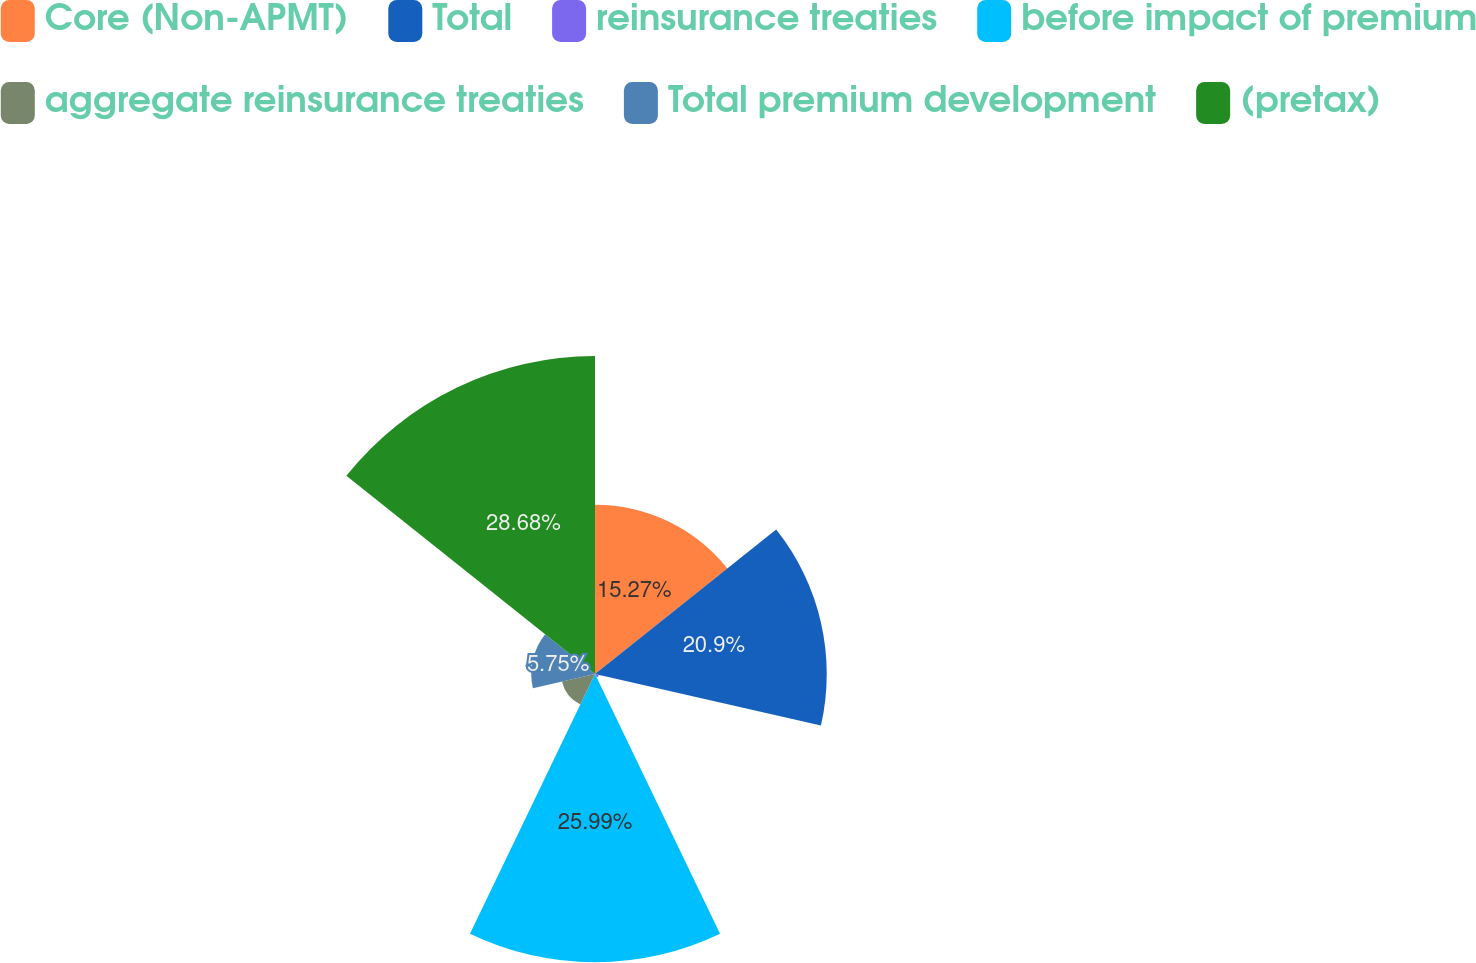Convert chart to OTSL. <chart><loc_0><loc_0><loc_500><loc_500><pie_chart><fcel>Core (Non-APMT)<fcel>Total<fcel>reinsurance treaties<fcel>before impact of premium<fcel>aggregate reinsurance treaties<fcel>Total premium development<fcel>(pretax)<nl><fcel>15.27%<fcel>20.9%<fcel>0.36%<fcel>25.99%<fcel>3.05%<fcel>5.75%<fcel>28.68%<nl></chart> 